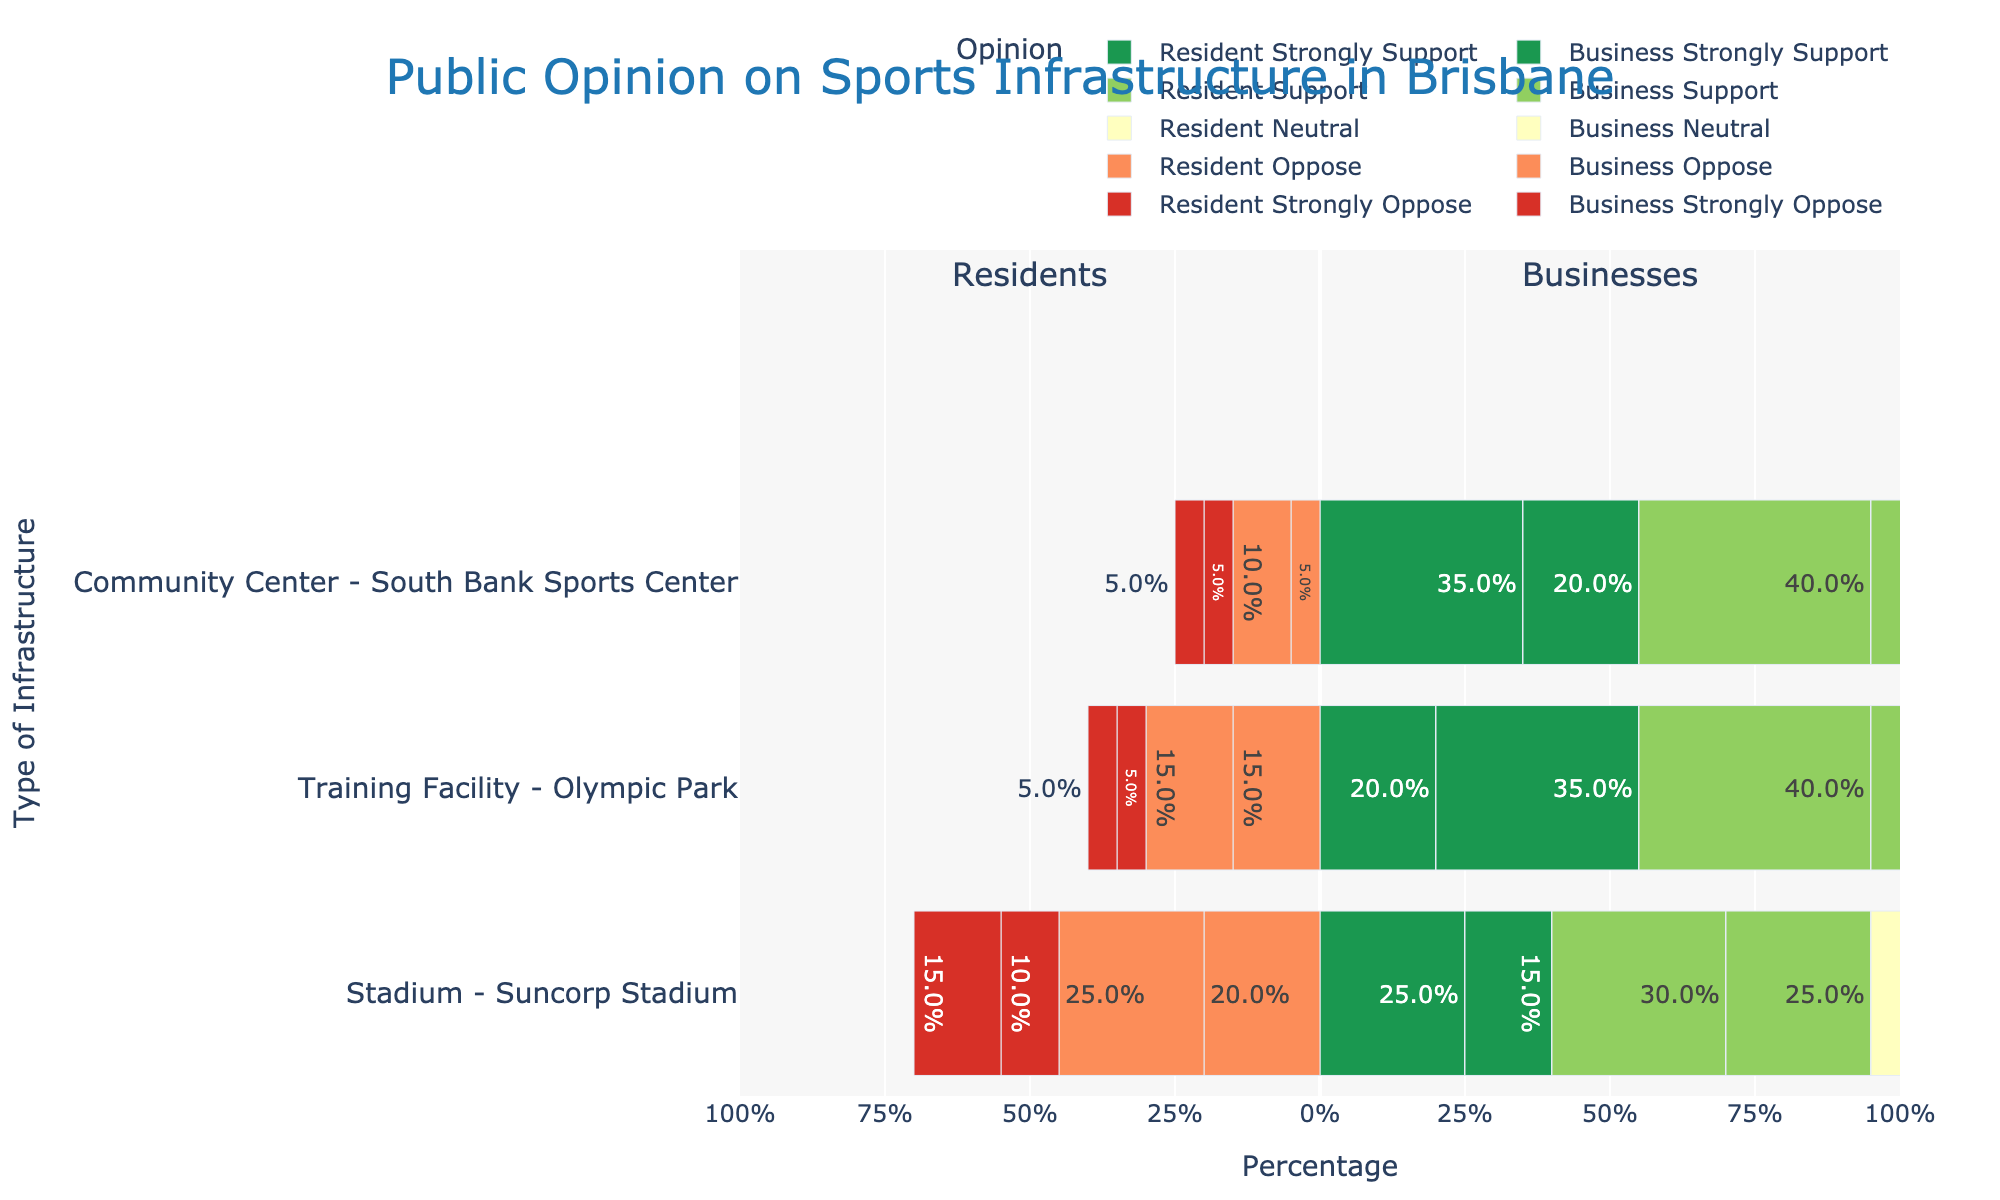Which type of sports infrastructure has the highest percentage of residents strongly supporting it? By looking at the bars for 'Strongly Support' among residents across all types of sports infrastructure, we see the longest green bar is for 'Community Center - South Bank Sports Center'. Hence, this has the highest percentage of residents strongly supporting it.
Answer: Community Center - South Bank Sports Center What is the difference in percentage between residents and businesses strongly supporting Training Facility - Olympic Park? The percentage of residents strongly supporting Training Facility - Olympic Park is 20%, and the percentage of businesses strongly supporting it is 35%. The difference is 35% - 20% = 15%.
Answer: 15% How does the support level for the stadium compare between residents and businesses? To compare, we look at the 'Support' segment for both residents and businesses regarding the stadium. Residents show 30% support while businesses show 25%. This indicates residents support the stadium more than businesses by 5%.
Answer: Residents support more by 5% Which opinion type shows the least difference in percentage between residents and businesses for Community Center - South Bank Sports Center? For each opinion type concerning Community Center - South Bank Sports Center, the differences are: Strongly Support (15%), Support (0%), Neutral (10%), Oppose (5%), and Strongly Oppose (0%). The least and equal differences are in 'Support' and 'Strongly Oppose' (0%).
Answer: Support and Strongly Oppose What is the total percentage of residents who oppose or strongly oppose Training Facility - Olympic Park? Adding the percentages for 'Oppose' and 'Strongly Oppose' among residents for Training Facility - Olympic Park, we get 15% + 5% = 20%.
Answer: 20% Which type of infrastructure do businesses neutral the most? By looking at the 'Neutral' bars for businesses across all types of sports infrastructure, we find the longest yellow bar is for 'Community Center - South Bank Sports Center' at 25%.
Answer: Community Center - South Bank Sports Center Are the levels of strong opposition relatively the same across all types of infrastructure for residents? Observing the 'Strongly Oppose' segments for residents, the percentages are 10% for Stadium - Suncorp Stadium, 5% for Training Facility - Olympic Park, and 5% for Community Center - South Bank Sports Center. 'Stadium - Suncorp Stadium' shows a different value, suggesting they are not relatively the same.
Answer: No Which opinions do residents have a higher percentage than businesses for Training Facility - Olympic Park? Examining the bars for residents and businesses for the Training Facility - Olympic Park, the opinions are: 'Support' where residents' percentage is 40% (higher than businesses' 30%), and 'Strongly Oppose' where both have an equal percentage. The answer is 'Support'.
Answer: Support 